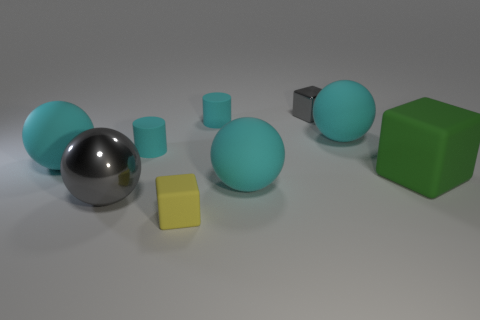Subtract all brown cubes. How many cyan spheres are left? 3 Subtract all big gray spheres. How many spheres are left? 3 Add 1 big green matte things. How many objects exist? 10 Subtract all cubes. How many objects are left? 6 Subtract 0 blue balls. How many objects are left? 9 Subtract all big metallic things. Subtract all cyan objects. How many objects are left? 3 Add 3 small cyan cylinders. How many small cyan cylinders are left? 5 Add 1 small red balls. How many small red balls exist? 1 